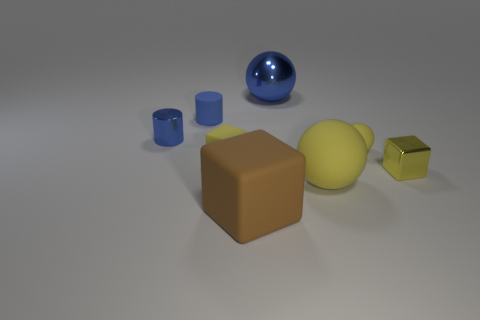Are there any other things that are the same material as the big cube?
Give a very brief answer. Yes. The yellow matte thing that is the same shape as the big brown rubber object is what size?
Provide a succinct answer. Small. Are there any small things to the right of the tiny blue shiny cylinder?
Offer a very short reply. Yes. Is the number of tiny objects in front of the yellow matte cube the same as the number of yellow things?
Ensure brevity in your answer.  No. Are there any large rubber cubes that are behind the small cylinder in front of the tiny blue cylinder that is behind the blue metallic cylinder?
Make the answer very short. No. What material is the brown thing?
Offer a very short reply. Rubber. How many other things are there of the same shape as the big blue shiny thing?
Offer a very short reply. 2. Is the shape of the big blue thing the same as the yellow metal thing?
Keep it short and to the point. No. How many things are either yellow matte spheres that are behind the metallic cube or yellow objects that are to the left of the yellow metallic thing?
Offer a very short reply. 3. What number of objects are either large blue matte cubes or brown blocks?
Provide a succinct answer. 1. 